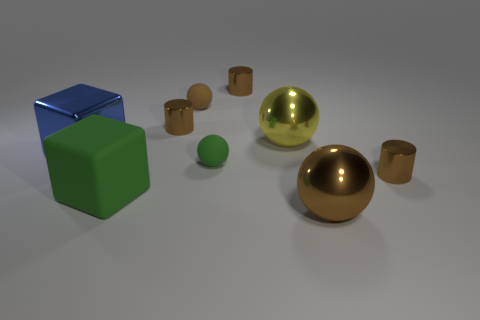Is there a purple shiny cylinder that has the same size as the blue object?
Ensure brevity in your answer.  No. Is the number of green cubes that are behind the blue shiny cube the same as the number of big cubes that are behind the small brown rubber object?
Ensure brevity in your answer.  Yes. Does the brown sphere that is behind the big yellow metal ball have the same material as the tiny cylinder to the right of the yellow metallic object?
Provide a short and direct response. No. What is the tiny brown sphere made of?
Your answer should be compact. Rubber. How many other objects are the same color as the large shiny cube?
Provide a succinct answer. 0. Is the big matte thing the same color as the metal block?
Keep it short and to the point. No. How many blue matte things are there?
Give a very brief answer. 0. There is a tiny cylinder to the right of the tiny brown cylinder that is behind the small brown matte sphere; what is its material?
Keep it short and to the point. Metal. What material is the green ball that is the same size as the brown rubber ball?
Make the answer very short. Rubber. There is a brown metal cylinder that is in front of the yellow metallic thing; is it the same size as the large rubber cube?
Keep it short and to the point. No. 